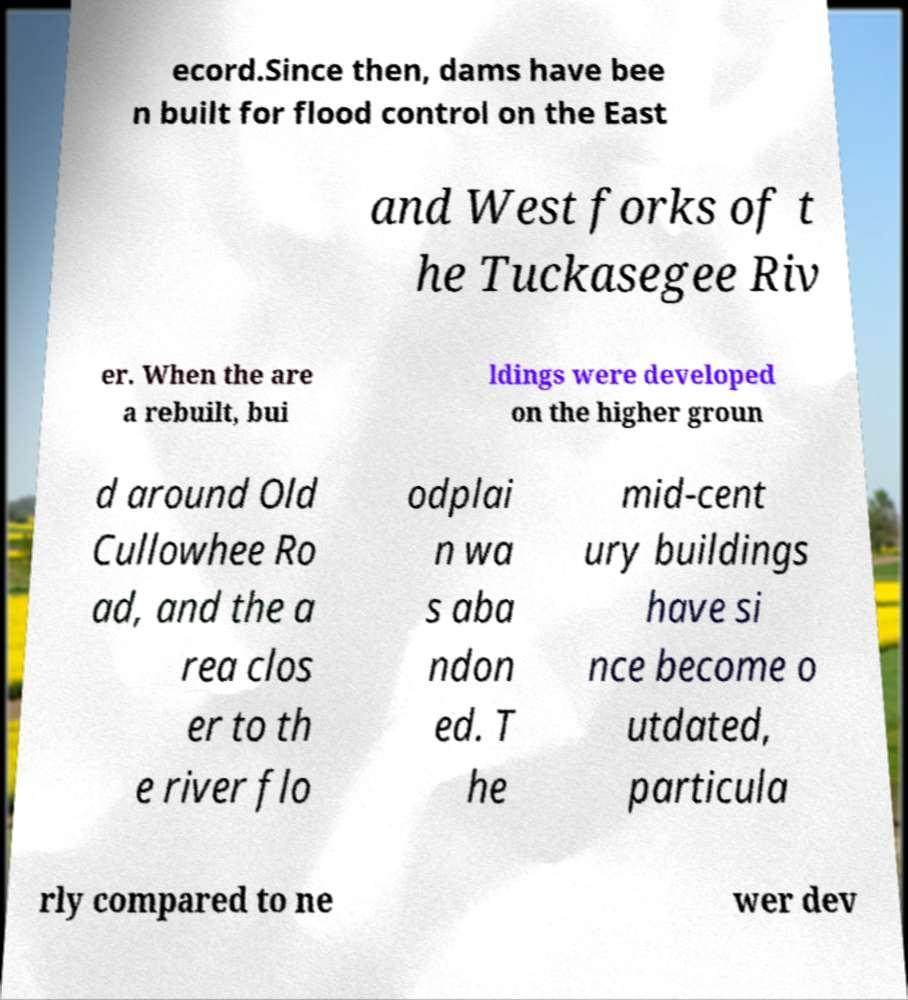Please read and relay the text visible in this image. What does it say? ecord.Since then, dams have bee n built for flood control on the East and West forks of t he Tuckasegee Riv er. When the are a rebuilt, bui ldings were developed on the higher groun d around Old Cullowhee Ro ad, and the a rea clos er to th e river flo odplai n wa s aba ndon ed. T he mid-cent ury buildings have si nce become o utdated, particula rly compared to ne wer dev 